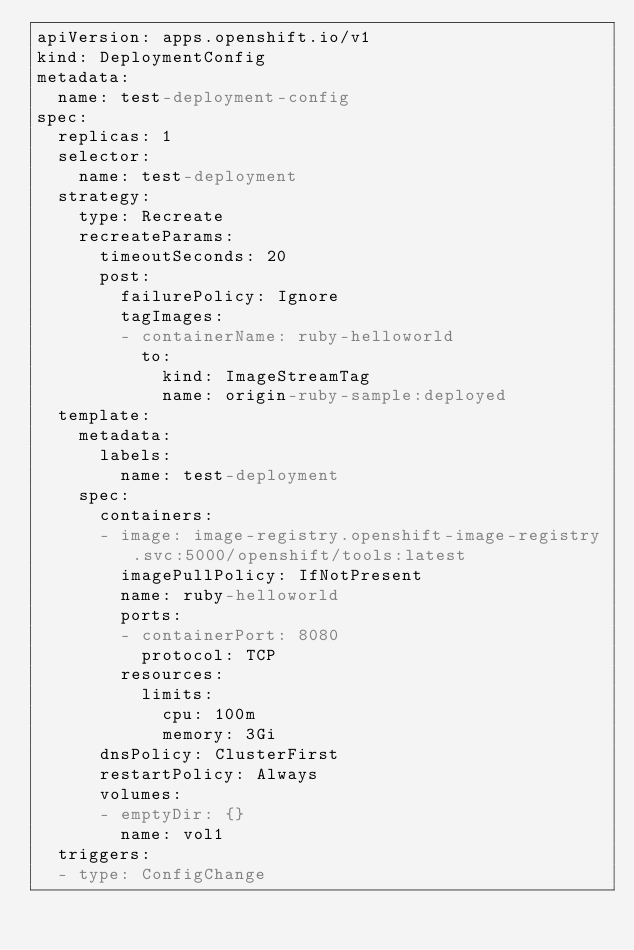<code> <loc_0><loc_0><loc_500><loc_500><_YAML_>apiVersion: apps.openshift.io/v1
kind: DeploymentConfig
metadata:
  name: test-deployment-config
spec:
  replicas: 1
  selector:
    name: test-deployment
  strategy:
    type: Recreate
    recreateParams:
      timeoutSeconds: 20
      post:
        failurePolicy: Ignore
        tagImages:
        - containerName: ruby-helloworld
          to:
            kind: ImageStreamTag
            name: origin-ruby-sample:deployed
  template:
    metadata:
      labels:
        name: test-deployment
    spec:
      containers:
      - image: image-registry.openshift-image-registry.svc:5000/openshift/tools:latest
        imagePullPolicy: IfNotPresent
        name: ruby-helloworld
        ports:
        - containerPort: 8080
          protocol: TCP
        resources:
          limits:
            cpu: 100m
            memory: 3Gi
      dnsPolicy: ClusterFirst
      restartPolicy: Always
      volumes:
      - emptyDir: {}
        name: vol1
  triggers:
  - type: ConfigChange
</code> 